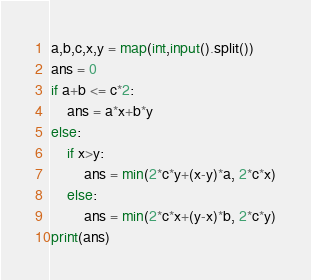Convert code to text. <code><loc_0><loc_0><loc_500><loc_500><_Python_>a,b,c,x,y = map(int,input().split())
ans = 0
if a+b <= c*2:
    ans = a*x+b*y
else:
    if x>y:
        ans = min(2*c*y+(x-y)*a, 2*c*x)
    else:
        ans = min(2*c*x+(y-x)*b, 2*c*y)
print(ans)</code> 